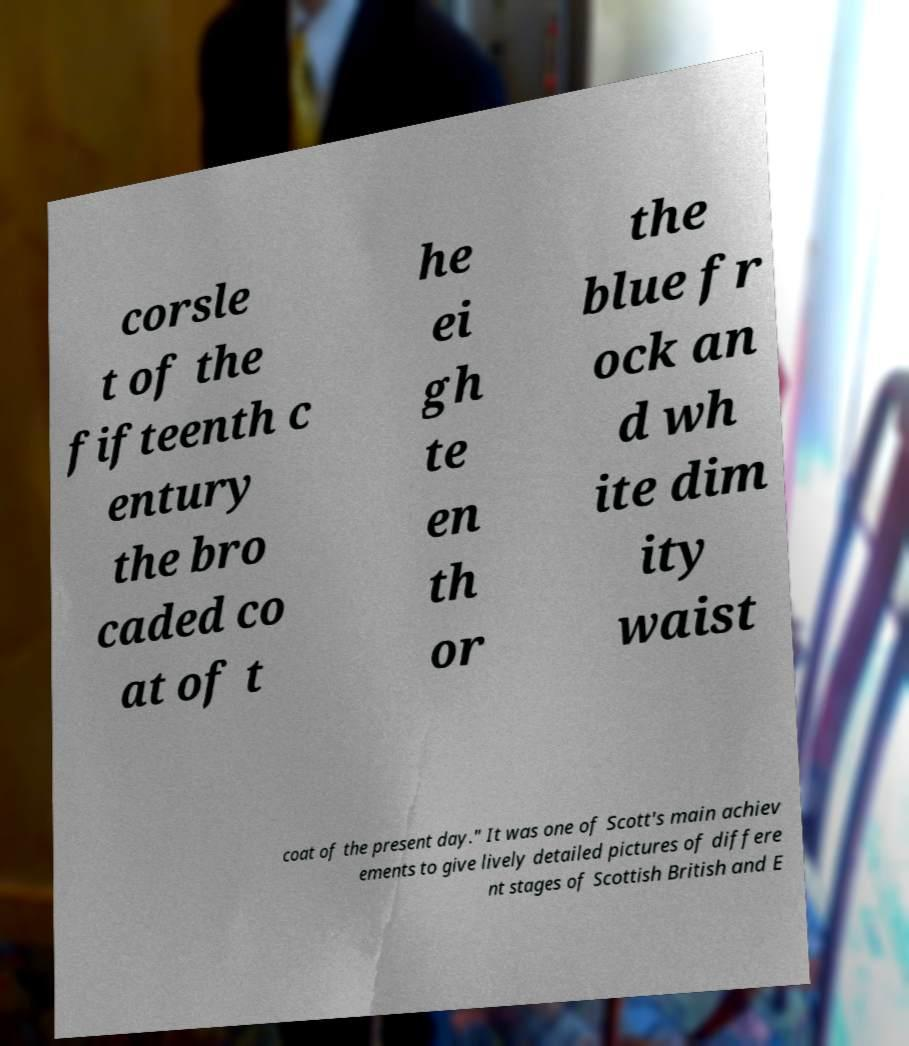What messages or text are displayed in this image? I need them in a readable, typed format. corsle t of the fifteenth c entury the bro caded co at of t he ei gh te en th or the blue fr ock an d wh ite dim ity waist coat of the present day." It was one of Scott's main achiev ements to give lively detailed pictures of differe nt stages of Scottish British and E 